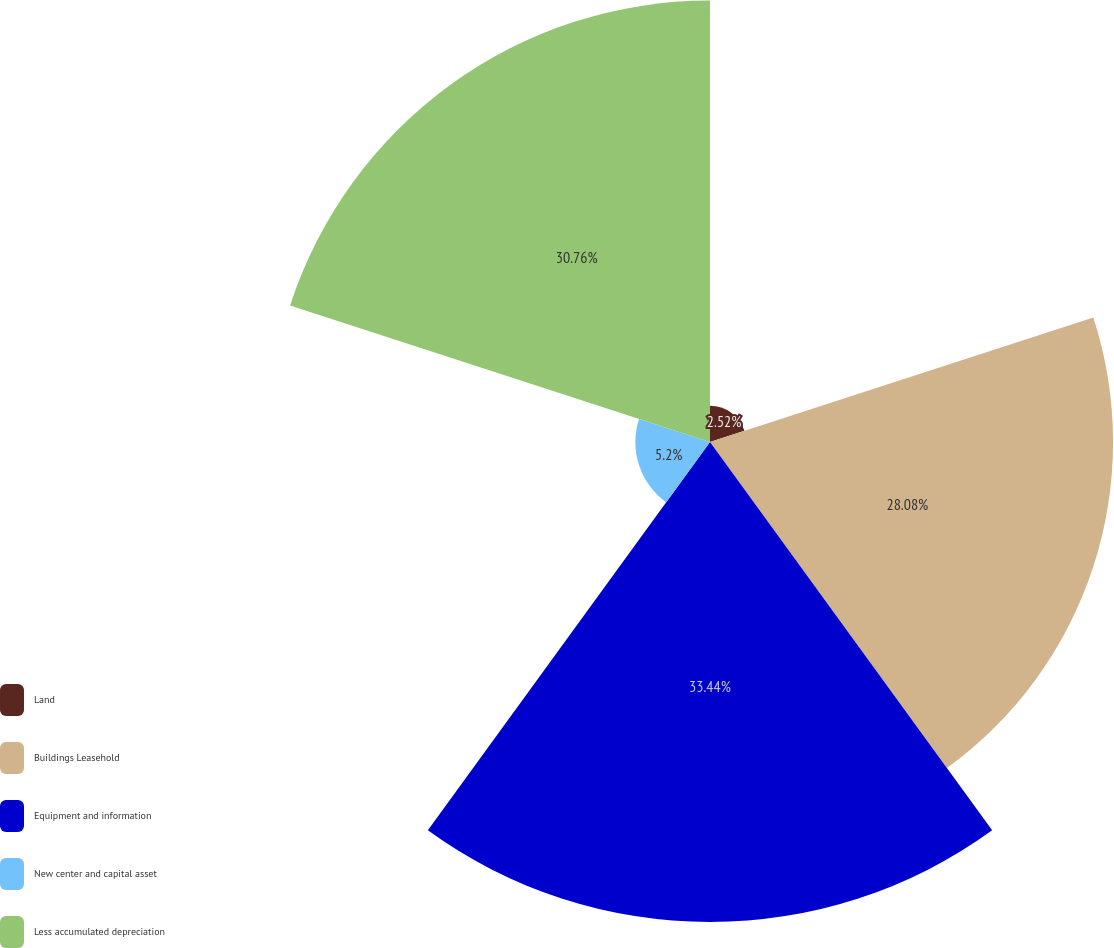<chart> <loc_0><loc_0><loc_500><loc_500><pie_chart><fcel>Land<fcel>Buildings Leasehold<fcel>Equipment and information<fcel>New center and capital asset<fcel>Less accumulated depreciation<nl><fcel>2.52%<fcel>28.08%<fcel>33.44%<fcel>5.2%<fcel>30.76%<nl></chart> 